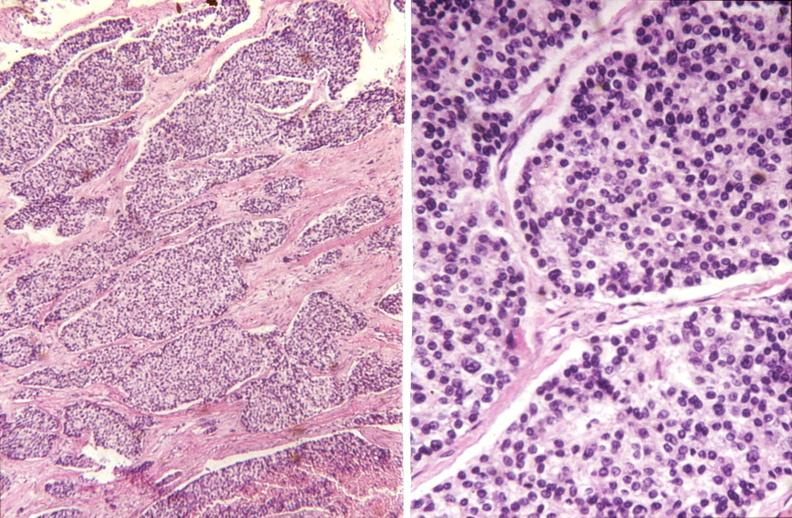what is present?
Answer the question using a single word or phrase. Endocrine 